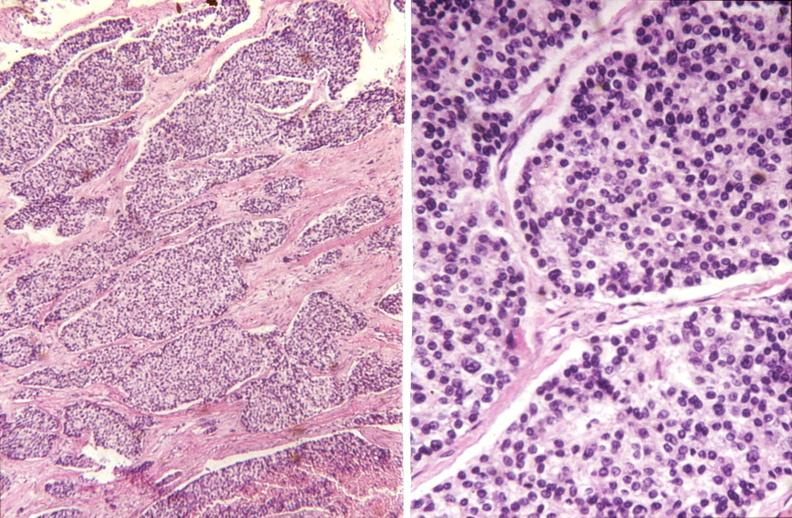what is present?
Answer the question using a single word or phrase. Endocrine 